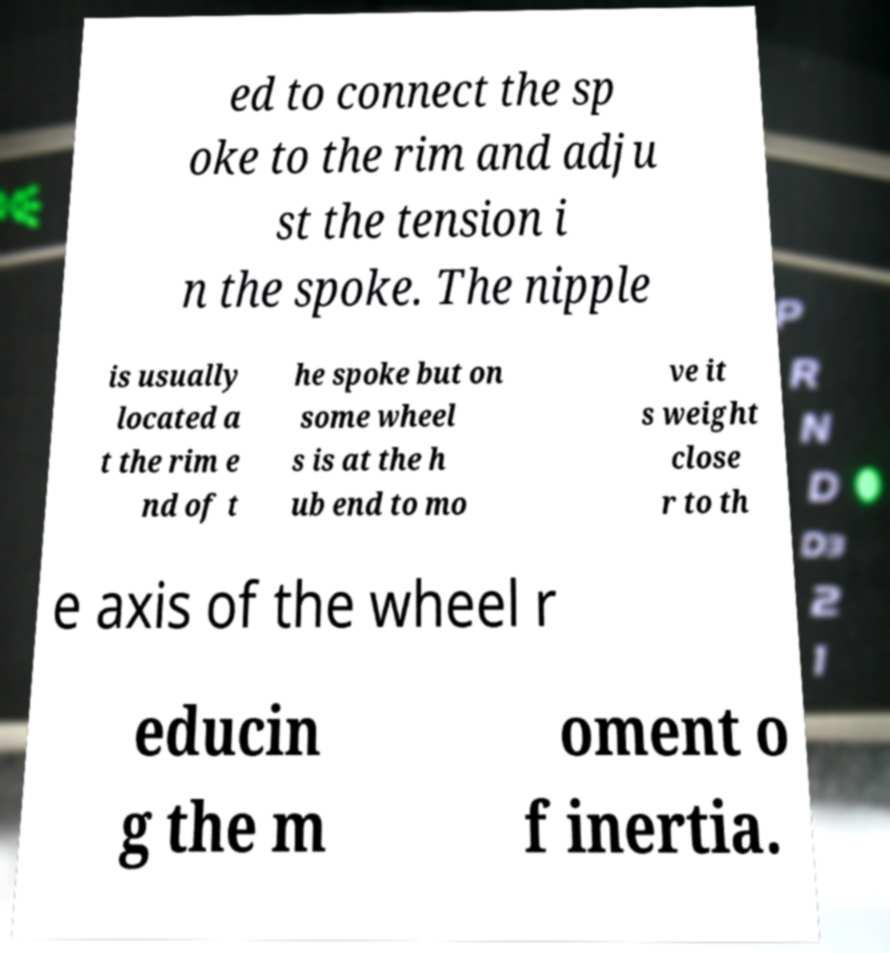Can you read and provide the text displayed in the image?This photo seems to have some interesting text. Can you extract and type it out for me? ed to connect the sp oke to the rim and adju st the tension i n the spoke. The nipple is usually located a t the rim e nd of t he spoke but on some wheel s is at the h ub end to mo ve it s weight close r to th e axis of the wheel r educin g the m oment o f inertia. 